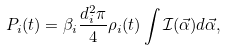Convert formula to latex. <formula><loc_0><loc_0><loc_500><loc_500>P _ { i } ( t ) = \beta _ { i } \frac { d _ { i } ^ { 2 } \pi } { 4 } \rho _ { i } ( t ) \int \mathcal { I } ( \vec { \alpha } ) d \vec { \alpha } ,</formula> 